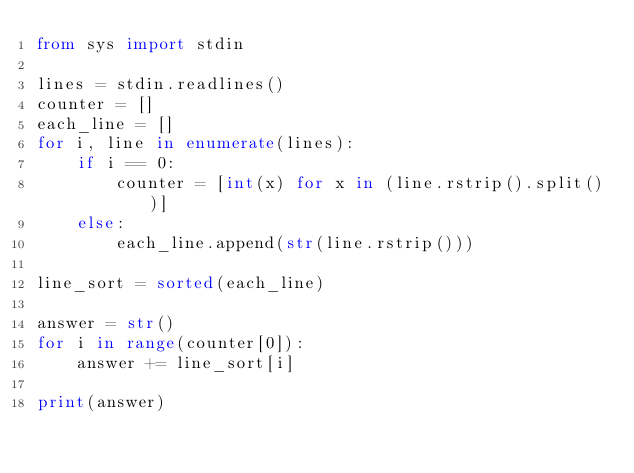Convert code to text. <code><loc_0><loc_0><loc_500><loc_500><_Python_>from sys import stdin

lines = stdin.readlines()
counter = []
each_line = []
for i, line in enumerate(lines):
    if i == 0:
        counter = [int(x) for x in (line.rstrip().split())]
    else:
        each_line.append(str(line.rstrip()))

line_sort = sorted(each_line)

answer = str()
for i in range(counter[0]):
    answer += line_sort[i]

print(answer)</code> 